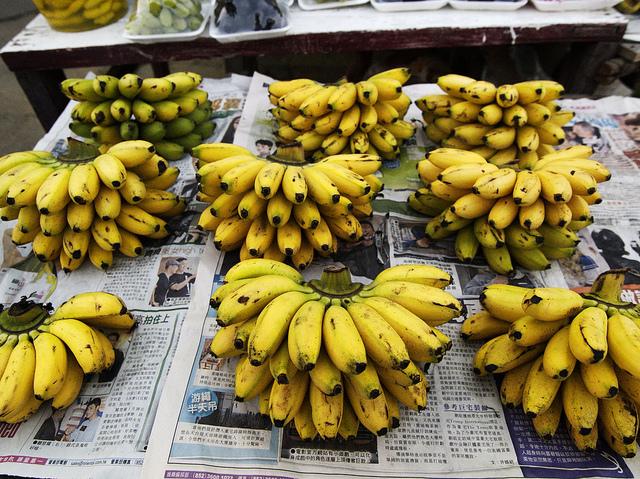Is this photo probably taking in the United States?
Give a very brief answer. No. Are the fruits ripe?
Be succinct. Yes. What fruit is on the newspaper?
Give a very brief answer. Bananas. 